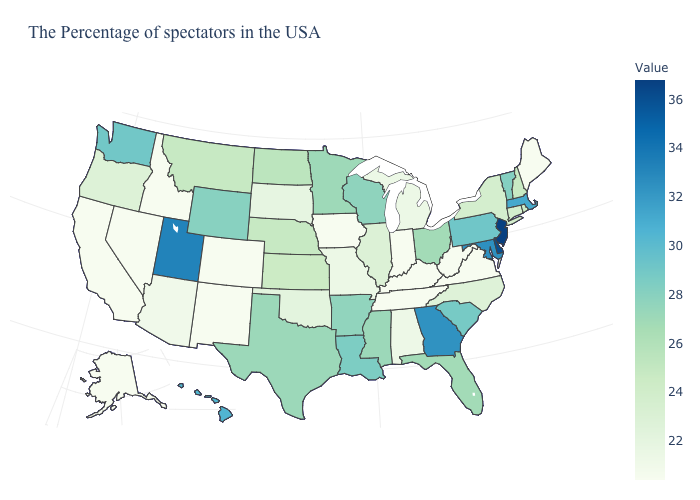Does Maine have the lowest value in the Northeast?
Answer briefly. Yes. Which states have the lowest value in the USA?
Keep it brief. Maine, Virginia, West Virginia, Kentucky, Indiana, Tennessee, Iowa, Colorado, New Mexico, Idaho, Nevada, California, Alaska. Does Massachusetts have the lowest value in the USA?
Write a very short answer. No. Among the states that border New Mexico , does Utah have the lowest value?
Write a very short answer. No. Does Kansas have a higher value than Alabama?
Short answer required. Yes. Does Rhode Island have the highest value in the USA?
Write a very short answer. No. Does North Carolina have the lowest value in the USA?
Quick response, please. No. 